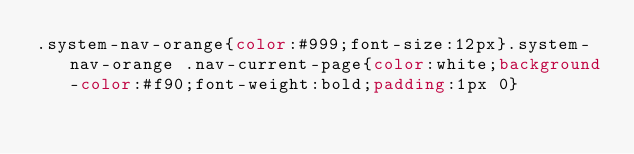<code> <loc_0><loc_0><loc_500><loc_500><_CSS_>.system-nav-orange{color:#999;font-size:12px}.system-nav-orange .nav-current-page{color:white;background-color:#f90;font-weight:bold;padding:1px 0}</code> 